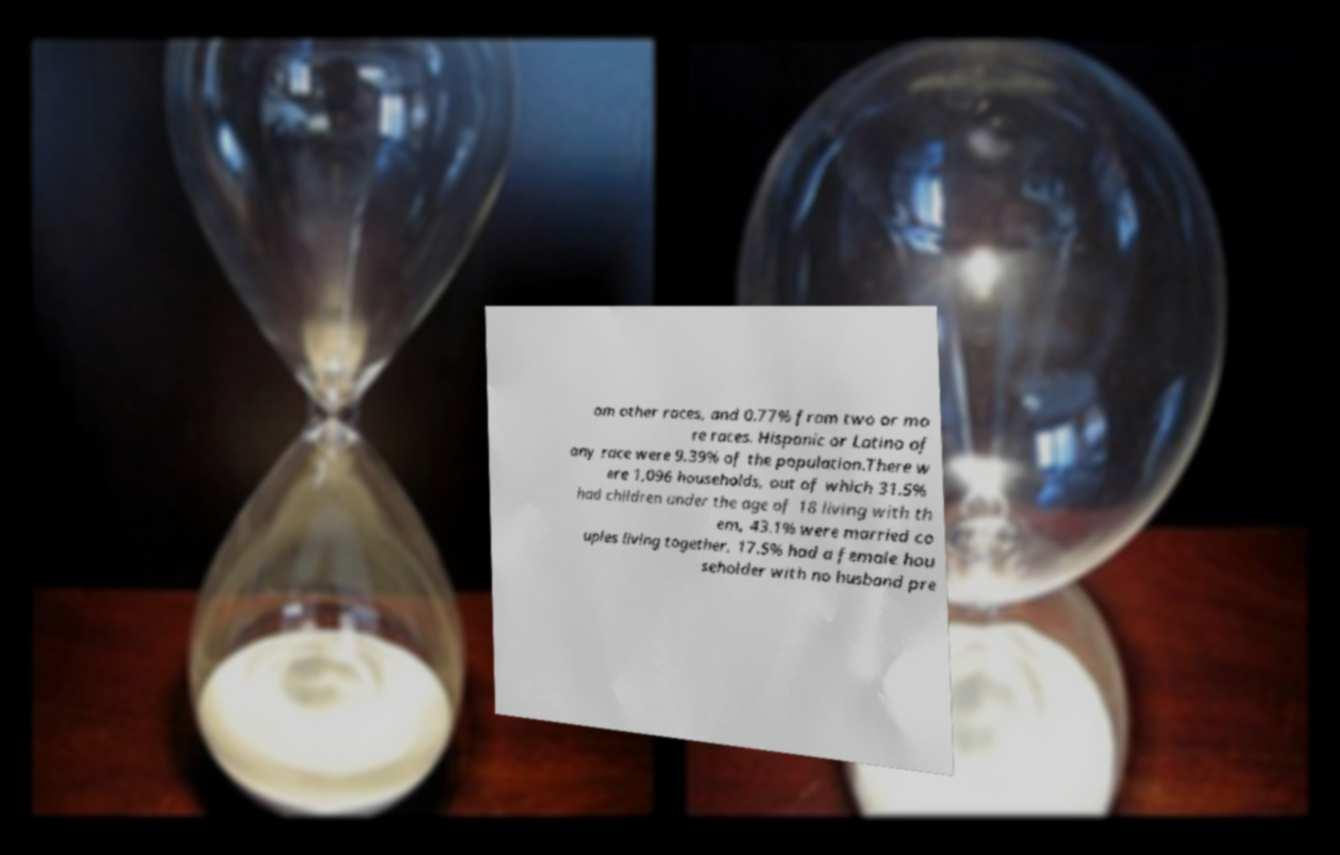For documentation purposes, I need the text within this image transcribed. Could you provide that? om other races, and 0.77% from two or mo re races. Hispanic or Latino of any race were 9.39% of the population.There w ere 1,096 households, out of which 31.5% had children under the age of 18 living with th em, 43.1% were married co uples living together, 17.5% had a female hou seholder with no husband pre 